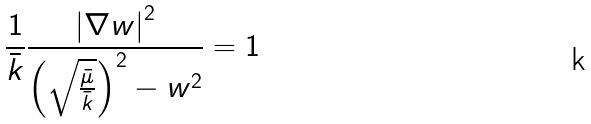<formula> <loc_0><loc_0><loc_500><loc_500>\frac { 1 } { \bar { k } } \frac { \left | \nabla w \right | ^ { 2 } } { \left ( \sqrt { \frac { \bar { \mu } } { \bar { k } } } \right ) ^ { 2 } - w ^ { 2 } } = 1</formula> 